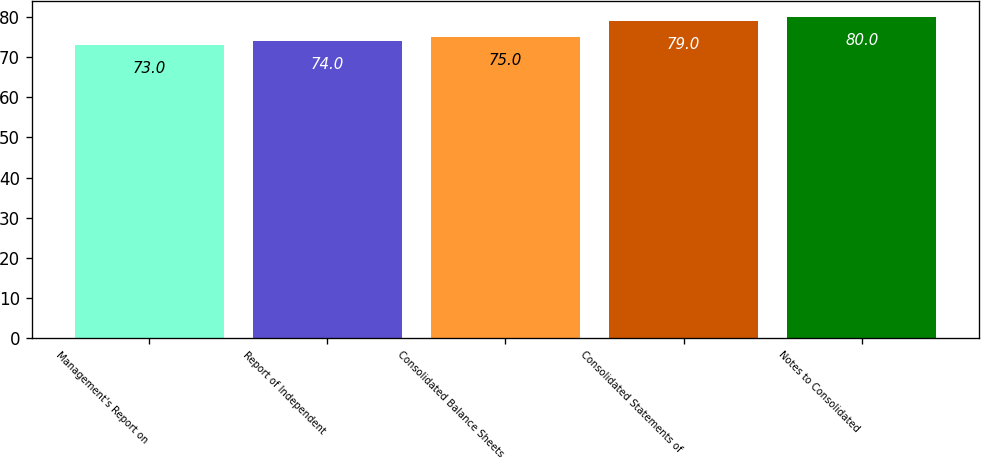<chart> <loc_0><loc_0><loc_500><loc_500><bar_chart><fcel>Management's Report on<fcel>Report of Independent<fcel>Consolidated Balance Sheets<fcel>Consolidated Statements of<fcel>Notes to Consolidated<nl><fcel>73<fcel>74<fcel>75<fcel>79<fcel>80<nl></chart> 